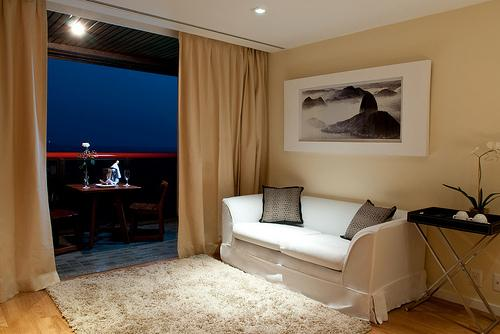Mention a key piece of furniture and specify details about its color and appearance. There is a solid white couch with rounded arms and back, situated against the wall. List any object that has a floral element and describe its appearance. A single pink rose rests in a crystal vase, adding a touch of elegance to the setting. Mention some of the items found outside the terrace, paying attention to detail. There is a red metal balcony barrier gate and a dining table and chairs set up for outdoor dining. Describe the pillows found on the couch, focusing on their color and design. There are black and grey throw pillows with the dominant colors and some minor trims on the couch. What type of wall decoration is visible and what colors does it have? There is a black and white art print with a white frame displayed on the wall. 